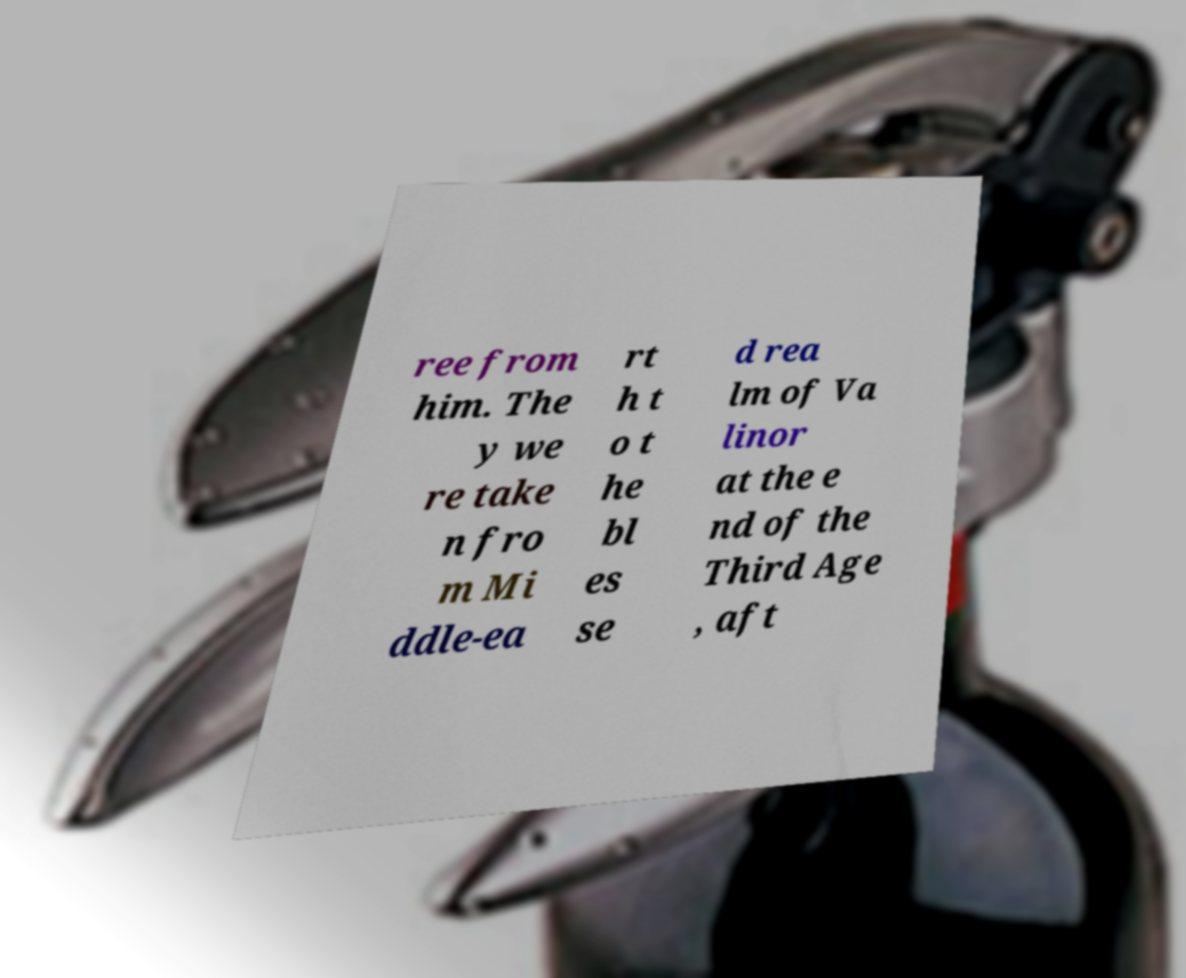For documentation purposes, I need the text within this image transcribed. Could you provide that? ree from him. The y we re take n fro m Mi ddle-ea rt h t o t he bl es se d rea lm of Va linor at the e nd of the Third Age , aft 